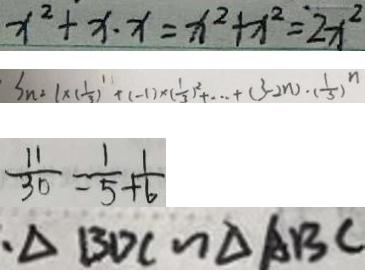<formula> <loc_0><loc_0><loc_500><loc_500>x ^ { 2 } + x \cdot x = x ^ { 2 } + x ^ { 2 } = 2 x ^ { 2 } 
 S _ { n ^ { 2 } } = 1 \times ( \frac { 1 } { 3 } ) ^ { 1 } + ( - 1 ) \times ( \frac { 1 } { 3 } ) ^ { 2 } + \cdots + ( 3 - 2 n ) \cdot ( \frac { 1 } { 3 } ) ^ { n } 
 \frac { 1 1 } { 3 0 } = \frac { 1 } { 5 } + \frac { 1 } { 6 } 
 、 \Delta B D C \sim \Delta A B C</formula> 